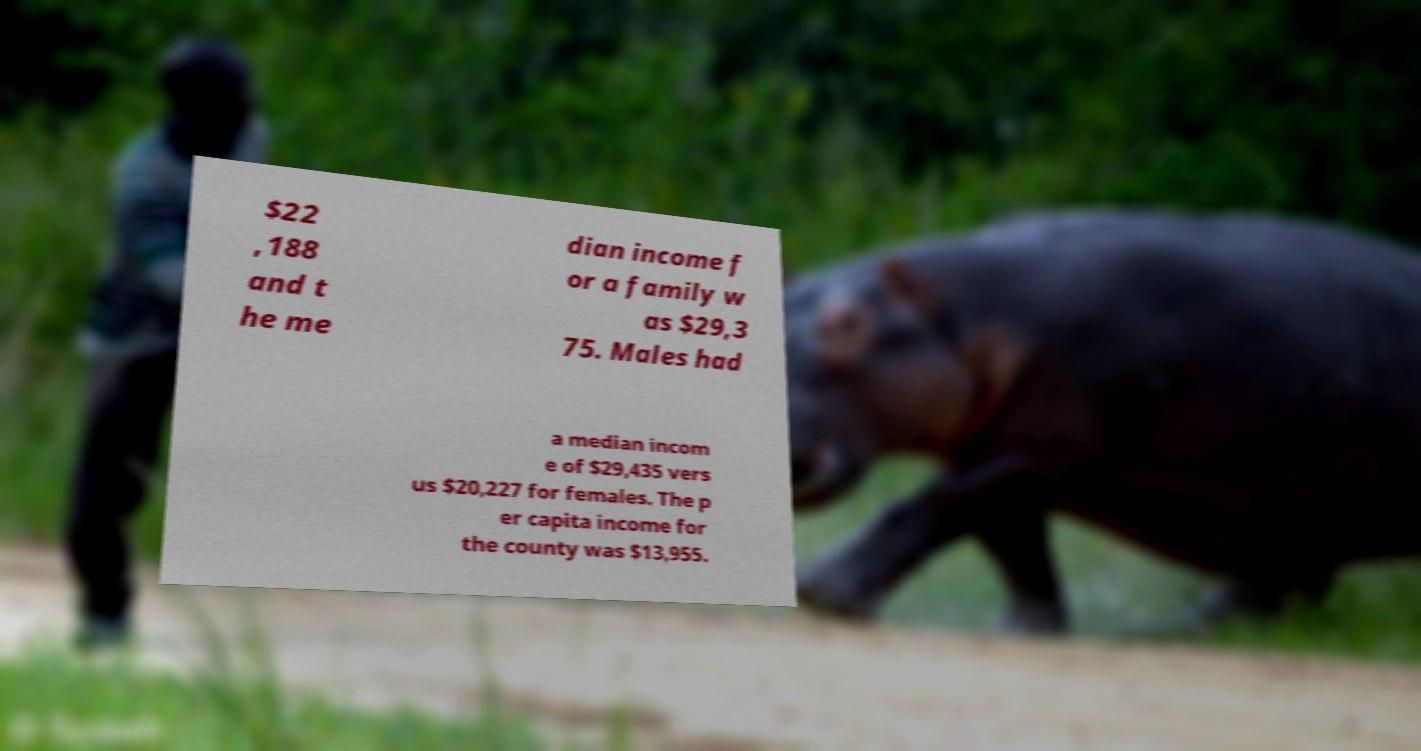Can you read and provide the text displayed in the image?This photo seems to have some interesting text. Can you extract and type it out for me? $22 ,188 and t he me dian income f or a family w as $29,3 75. Males had a median incom e of $29,435 vers us $20,227 for females. The p er capita income for the county was $13,955. 